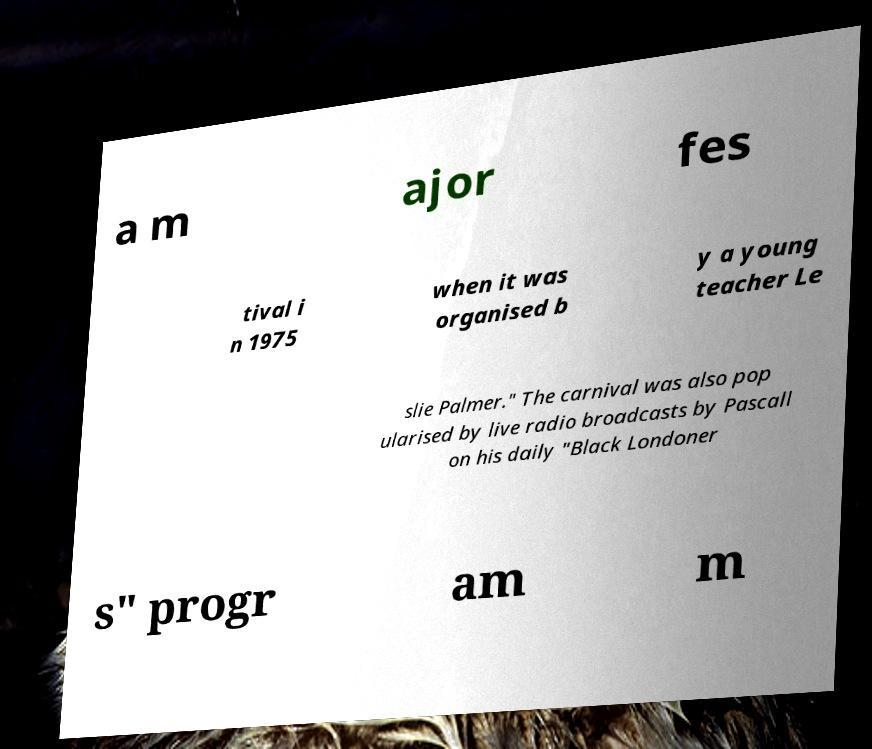Please read and relay the text visible in this image. What does it say? a m ajor fes tival i n 1975 when it was organised b y a young teacher Le slie Palmer." The carnival was also pop ularised by live radio broadcasts by Pascall on his daily "Black Londoner s" progr am m 